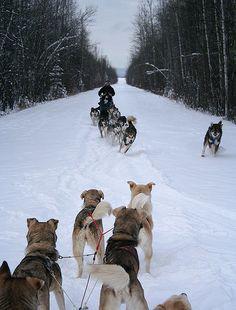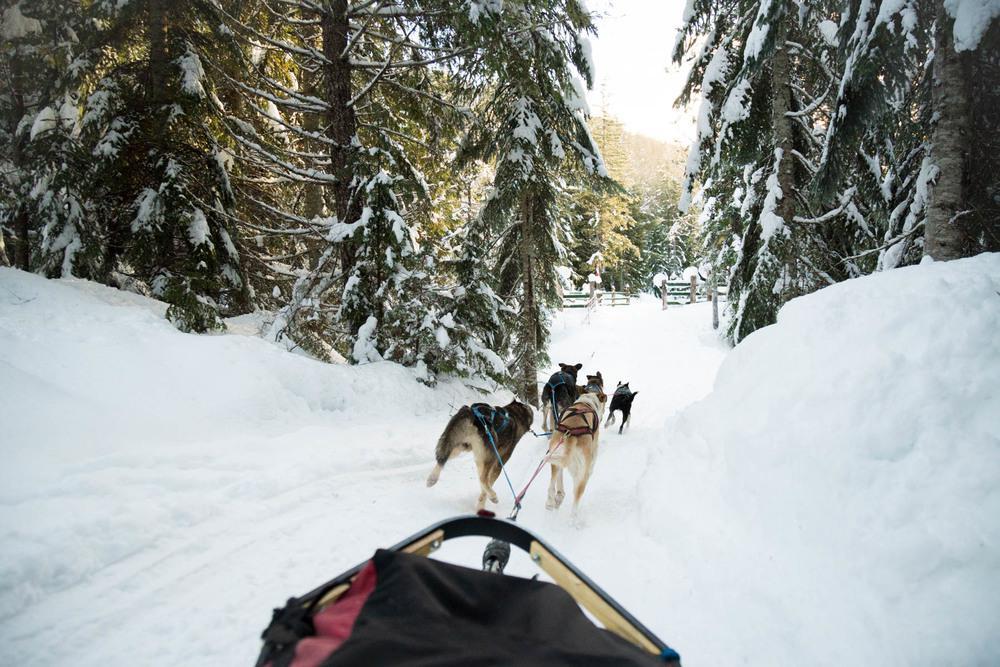The first image is the image on the left, the second image is the image on the right. Given the left and right images, does the statement "Each image includes a sled dog team facing away from the camera toward a trail lined with trees." hold true? Answer yes or no. Yes. 